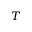<formula> <loc_0><loc_0><loc_500><loc_500>T</formula> 